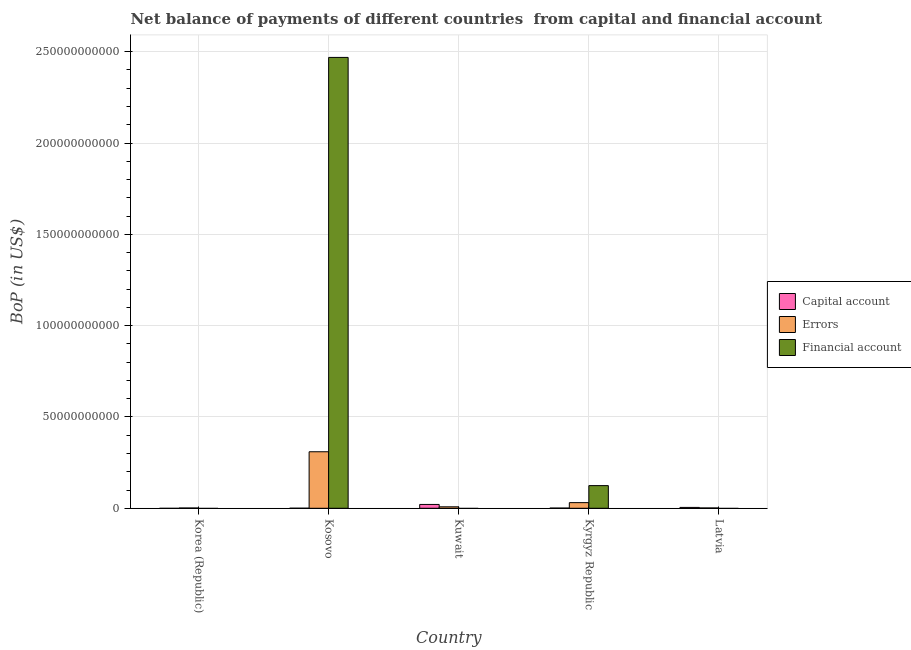How many bars are there on the 5th tick from the left?
Ensure brevity in your answer.  2. How many bars are there on the 5th tick from the right?
Provide a succinct answer. 1. What is the label of the 4th group of bars from the left?
Make the answer very short. Kyrgyz Republic. In how many cases, is the number of bars for a given country not equal to the number of legend labels?
Provide a short and direct response. 3. What is the amount of financial account in Latvia?
Ensure brevity in your answer.  0. Across all countries, what is the maximum amount of errors?
Ensure brevity in your answer.  3.09e+1. In which country was the amount of errors maximum?
Provide a short and direct response. Kosovo. What is the total amount of errors in the graph?
Ensure brevity in your answer.  3.51e+1. What is the difference between the amount of errors in Kosovo and that in Kuwait?
Offer a very short reply. 3.01e+1. What is the difference between the amount of financial account in Kyrgyz Republic and the amount of errors in Latvia?
Make the answer very short. 1.22e+1. What is the average amount of net capital account per country?
Provide a succinct answer. 5.41e+08. What is the difference between the amount of financial account and amount of errors in Kosovo?
Offer a very short reply. 2.16e+11. In how many countries, is the amount of net capital account greater than 20000000000 US$?
Ensure brevity in your answer.  0. What is the ratio of the amount of financial account in Kosovo to that in Kyrgyz Republic?
Keep it short and to the point. 19.91. Is the amount of errors in Korea (Republic) less than that in Kosovo?
Keep it short and to the point. Yes. Is the difference between the amount of errors in Kosovo and Kyrgyz Republic greater than the difference between the amount of net capital account in Kosovo and Kyrgyz Republic?
Provide a succinct answer. Yes. What is the difference between the highest and the second highest amount of errors?
Your response must be concise. 2.78e+1. What is the difference between the highest and the lowest amount of errors?
Offer a very short reply. 3.08e+1. Is it the case that in every country, the sum of the amount of net capital account and amount of errors is greater than the amount of financial account?
Make the answer very short. No. How many bars are there?
Your response must be concise. 11. Are all the bars in the graph horizontal?
Your answer should be very brief. No. How many countries are there in the graph?
Keep it short and to the point. 5. Does the graph contain grids?
Keep it short and to the point. Yes. How many legend labels are there?
Ensure brevity in your answer.  3. How are the legend labels stacked?
Ensure brevity in your answer.  Vertical. What is the title of the graph?
Offer a terse response. Net balance of payments of different countries  from capital and financial account. What is the label or title of the Y-axis?
Give a very brief answer. BoP (in US$). What is the BoP (in US$) in Capital account in Korea (Republic)?
Make the answer very short. 0. What is the BoP (in US$) of Errors in Korea (Republic)?
Your answer should be compact. 1.49e+08. What is the BoP (in US$) of Financial account in Korea (Republic)?
Offer a very short reply. 0. What is the BoP (in US$) in Capital account in Kosovo?
Ensure brevity in your answer.  2.67e+07. What is the BoP (in US$) of Errors in Kosovo?
Provide a succinct answer. 3.09e+1. What is the BoP (in US$) in Financial account in Kosovo?
Your response must be concise. 2.47e+11. What is the BoP (in US$) of Capital account in Kuwait?
Give a very brief answer. 2.10e+09. What is the BoP (in US$) in Errors in Kuwait?
Your response must be concise. 7.94e+08. What is the BoP (in US$) in Financial account in Kuwait?
Offer a very short reply. 0. What is the BoP (in US$) in Capital account in Kyrgyz Republic?
Your answer should be compact. 1.09e+08. What is the BoP (in US$) in Errors in Kyrgyz Republic?
Provide a succinct answer. 3.09e+09. What is the BoP (in US$) of Financial account in Kyrgyz Republic?
Ensure brevity in your answer.  1.24e+1. What is the BoP (in US$) in Capital account in Latvia?
Keep it short and to the point. 4.71e+08. What is the BoP (in US$) of Errors in Latvia?
Keep it short and to the point. 1.75e+08. What is the BoP (in US$) of Financial account in Latvia?
Provide a succinct answer. 0. Across all countries, what is the maximum BoP (in US$) in Capital account?
Offer a very short reply. 2.10e+09. Across all countries, what is the maximum BoP (in US$) of Errors?
Your answer should be very brief. 3.09e+1. Across all countries, what is the maximum BoP (in US$) of Financial account?
Your answer should be compact. 2.47e+11. Across all countries, what is the minimum BoP (in US$) of Errors?
Your response must be concise. 1.49e+08. Across all countries, what is the minimum BoP (in US$) of Financial account?
Ensure brevity in your answer.  0. What is the total BoP (in US$) in Capital account in the graph?
Your answer should be compact. 2.70e+09. What is the total BoP (in US$) in Errors in the graph?
Your answer should be very brief. 3.51e+1. What is the total BoP (in US$) in Financial account in the graph?
Your answer should be compact. 2.59e+11. What is the difference between the BoP (in US$) in Errors in Korea (Republic) and that in Kosovo?
Your answer should be compact. -3.08e+1. What is the difference between the BoP (in US$) of Errors in Korea (Republic) and that in Kuwait?
Your answer should be very brief. -6.45e+08. What is the difference between the BoP (in US$) in Errors in Korea (Republic) and that in Kyrgyz Republic?
Your answer should be compact. -2.94e+09. What is the difference between the BoP (in US$) of Errors in Korea (Republic) and that in Latvia?
Offer a very short reply. -2.60e+07. What is the difference between the BoP (in US$) in Capital account in Kosovo and that in Kuwait?
Your response must be concise. -2.07e+09. What is the difference between the BoP (in US$) of Errors in Kosovo and that in Kuwait?
Your response must be concise. 3.01e+1. What is the difference between the BoP (in US$) in Capital account in Kosovo and that in Kyrgyz Republic?
Your answer should be very brief. -8.19e+07. What is the difference between the BoP (in US$) of Errors in Kosovo and that in Kyrgyz Republic?
Make the answer very short. 2.78e+1. What is the difference between the BoP (in US$) in Financial account in Kosovo and that in Kyrgyz Republic?
Give a very brief answer. 2.34e+11. What is the difference between the BoP (in US$) of Capital account in Kosovo and that in Latvia?
Provide a succinct answer. -4.44e+08. What is the difference between the BoP (in US$) in Errors in Kosovo and that in Latvia?
Offer a terse response. 3.08e+1. What is the difference between the BoP (in US$) in Capital account in Kuwait and that in Kyrgyz Republic?
Give a very brief answer. 1.99e+09. What is the difference between the BoP (in US$) in Errors in Kuwait and that in Kyrgyz Republic?
Ensure brevity in your answer.  -2.30e+09. What is the difference between the BoP (in US$) in Capital account in Kuwait and that in Latvia?
Ensure brevity in your answer.  1.63e+09. What is the difference between the BoP (in US$) in Errors in Kuwait and that in Latvia?
Keep it short and to the point. 6.19e+08. What is the difference between the BoP (in US$) of Capital account in Kyrgyz Republic and that in Latvia?
Keep it short and to the point. -3.62e+08. What is the difference between the BoP (in US$) of Errors in Kyrgyz Republic and that in Latvia?
Provide a succinct answer. 2.92e+09. What is the difference between the BoP (in US$) of Errors in Korea (Republic) and the BoP (in US$) of Financial account in Kosovo?
Your answer should be compact. -2.47e+11. What is the difference between the BoP (in US$) in Errors in Korea (Republic) and the BoP (in US$) in Financial account in Kyrgyz Republic?
Provide a succinct answer. -1.23e+1. What is the difference between the BoP (in US$) of Capital account in Kosovo and the BoP (in US$) of Errors in Kuwait?
Offer a terse response. -7.67e+08. What is the difference between the BoP (in US$) of Capital account in Kosovo and the BoP (in US$) of Errors in Kyrgyz Republic?
Give a very brief answer. -3.06e+09. What is the difference between the BoP (in US$) in Capital account in Kosovo and the BoP (in US$) in Financial account in Kyrgyz Republic?
Your answer should be very brief. -1.24e+1. What is the difference between the BoP (in US$) of Errors in Kosovo and the BoP (in US$) of Financial account in Kyrgyz Republic?
Provide a short and direct response. 1.85e+1. What is the difference between the BoP (in US$) in Capital account in Kosovo and the BoP (in US$) in Errors in Latvia?
Provide a succinct answer. -1.49e+08. What is the difference between the BoP (in US$) in Capital account in Kuwait and the BoP (in US$) in Errors in Kyrgyz Republic?
Your response must be concise. -9.94e+08. What is the difference between the BoP (in US$) in Capital account in Kuwait and the BoP (in US$) in Financial account in Kyrgyz Republic?
Your answer should be compact. -1.03e+1. What is the difference between the BoP (in US$) in Errors in Kuwait and the BoP (in US$) in Financial account in Kyrgyz Republic?
Your answer should be compact. -1.16e+1. What is the difference between the BoP (in US$) in Capital account in Kuwait and the BoP (in US$) in Errors in Latvia?
Your response must be concise. 1.92e+09. What is the difference between the BoP (in US$) in Capital account in Kyrgyz Republic and the BoP (in US$) in Errors in Latvia?
Offer a terse response. -6.69e+07. What is the average BoP (in US$) of Capital account per country?
Your answer should be compact. 5.41e+08. What is the average BoP (in US$) in Errors per country?
Offer a terse response. 7.03e+09. What is the average BoP (in US$) in Financial account per country?
Offer a very short reply. 5.19e+1. What is the difference between the BoP (in US$) of Capital account and BoP (in US$) of Errors in Kosovo?
Provide a succinct answer. -3.09e+1. What is the difference between the BoP (in US$) in Capital account and BoP (in US$) in Financial account in Kosovo?
Give a very brief answer. -2.47e+11. What is the difference between the BoP (in US$) in Errors and BoP (in US$) in Financial account in Kosovo?
Your response must be concise. -2.16e+11. What is the difference between the BoP (in US$) of Capital account and BoP (in US$) of Errors in Kuwait?
Make the answer very short. 1.30e+09. What is the difference between the BoP (in US$) of Capital account and BoP (in US$) of Errors in Kyrgyz Republic?
Your answer should be compact. -2.98e+09. What is the difference between the BoP (in US$) in Capital account and BoP (in US$) in Financial account in Kyrgyz Republic?
Keep it short and to the point. -1.23e+1. What is the difference between the BoP (in US$) of Errors and BoP (in US$) of Financial account in Kyrgyz Republic?
Keep it short and to the point. -9.31e+09. What is the difference between the BoP (in US$) of Capital account and BoP (in US$) of Errors in Latvia?
Ensure brevity in your answer.  2.96e+08. What is the ratio of the BoP (in US$) of Errors in Korea (Republic) to that in Kosovo?
Your answer should be compact. 0. What is the ratio of the BoP (in US$) in Errors in Korea (Republic) to that in Kuwait?
Your answer should be compact. 0.19. What is the ratio of the BoP (in US$) in Errors in Korea (Republic) to that in Kyrgyz Republic?
Give a very brief answer. 0.05. What is the ratio of the BoP (in US$) in Errors in Korea (Republic) to that in Latvia?
Keep it short and to the point. 0.85. What is the ratio of the BoP (in US$) of Capital account in Kosovo to that in Kuwait?
Your answer should be compact. 0.01. What is the ratio of the BoP (in US$) in Errors in Kosovo to that in Kuwait?
Offer a terse response. 38.97. What is the ratio of the BoP (in US$) of Capital account in Kosovo to that in Kyrgyz Republic?
Provide a short and direct response. 0.25. What is the ratio of the BoP (in US$) in Errors in Kosovo to that in Kyrgyz Republic?
Your response must be concise. 10.01. What is the ratio of the BoP (in US$) in Financial account in Kosovo to that in Kyrgyz Republic?
Give a very brief answer. 19.91. What is the ratio of the BoP (in US$) in Capital account in Kosovo to that in Latvia?
Ensure brevity in your answer.  0.06. What is the ratio of the BoP (in US$) of Errors in Kosovo to that in Latvia?
Offer a terse response. 176.36. What is the ratio of the BoP (in US$) in Capital account in Kuwait to that in Kyrgyz Republic?
Provide a succinct answer. 19.31. What is the ratio of the BoP (in US$) of Errors in Kuwait to that in Kyrgyz Republic?
Offer a very short reply. 0.26. What is the ratio of the BoP (in US$) in Capital account in Kuwait to that in Latvia?
Make the answer very short. 4.45. What is the ratio of the BoP (in US$) of Errors in Kuwait to that in Latvia?
Your answer should be very brief. 4.53. What is the ratio of the BoP (in US$) in Capital account in Kyrgyz Republic to that in Latvia?
Your response must be concise. 0.23. What is the ratio of the BoP (in US$) in Errors in Kyrgyz Republic to that in Latvia?
Your response must be concise. 17.62. What is the difference between the highest and the second highest BoP (in US$) in Capital account?
Ensure brevity in your answer.  1.63e+09. What is the difference between the highest and the second highest BoP (in US$) of Errors?
Offer a very short reply. 2.78e+1. What is the difference between the highest and the lowest BoP (in US$) of Capital account?
Offer a very short reply. 2.10e+09. What is the difference between the highest and the lowest BoP (in US$) of Errors?
Provide a succinct answer. 3.08e+1. What is the difference between the highest and the lowest BoP (in US$) in Financial account?
Offer a very short reply. 2.47e+11. 